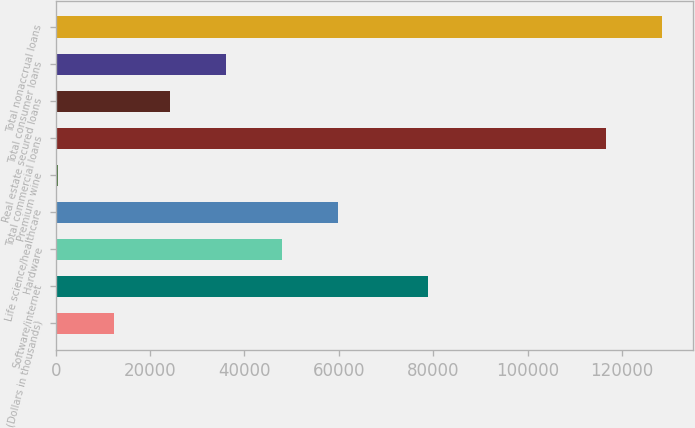Convert chart to OTSL. <chart><loc_0><loc_0><loc_500><loc_500><bar_chart><fcel>(Dollars in thousands)<fcel>Software/internet<fcel>Hardware<fcel>Life science/healthcare<fcel>Premium wine<fcel>Total commercial loans<fcel>Real estate secured loans<fcel>Total consumer loans<fcel>Total nonaccrual loans<nl><fcel>12286.8<fcel>78860<fcel>47944.2<fcel>59830<fcel>401<fcel>116656<fcel>24172.6<fcel>36058.4<fcel>128542<nl></chart> 